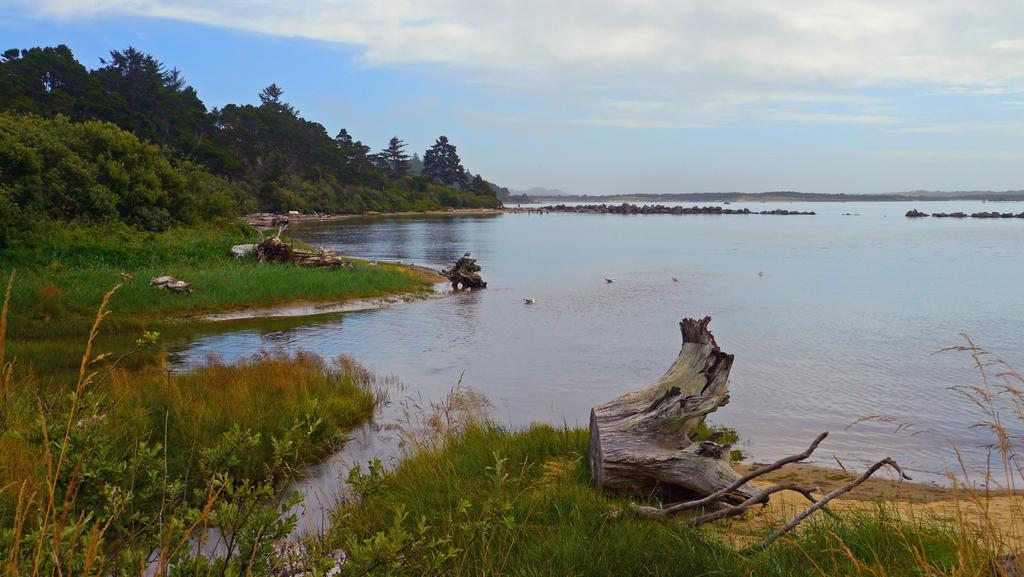What type of vegetation can be seen in the image? There are tree trunks and trees in the image. What type of ground cover is present in the image? There is grass in the image. What natural element is present in the image? There is water in the image. What part of the natural environment is visible in the image? The sky is visible in the image. Can you describe the setting where the image might have been taken? The image may have been taken near a lake, given the presence of water and trees. What is the income of the trees in the image? There is no income associated with the trees in the image, as trees are not capable of earning money. 